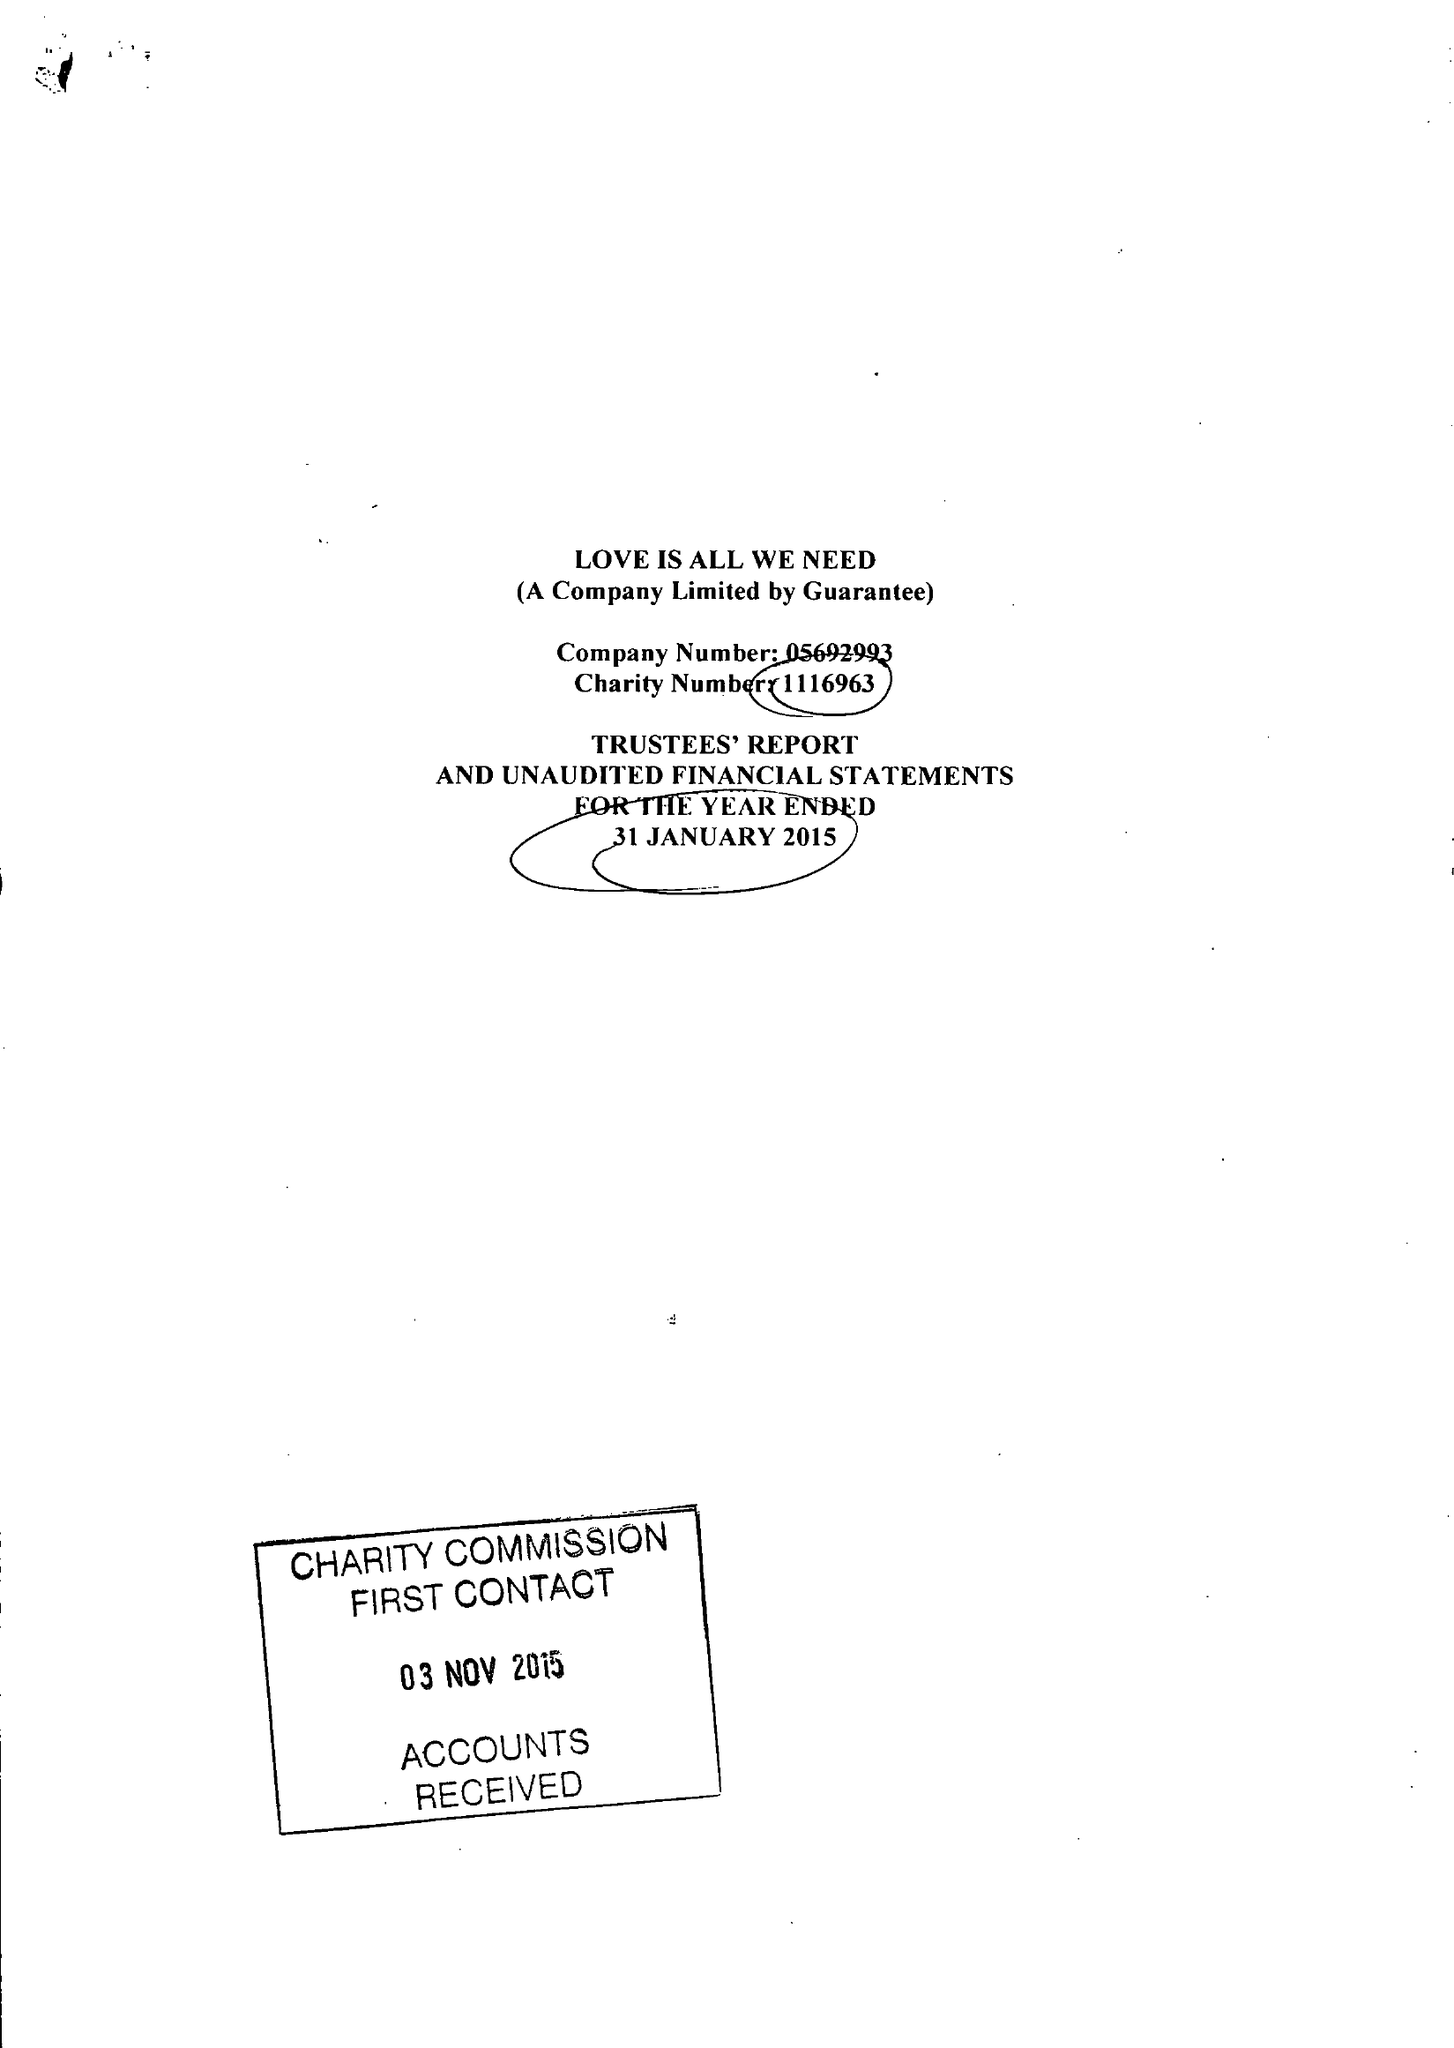What is the value for the charity_name?
Answer the question using a single word or phrase. Love Is All We Need 